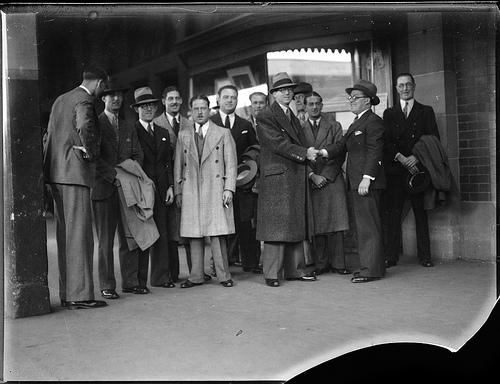What is holding his tie in place?
Write a very short answer. Jacket. How many hats are in the picture?
Answer briefly. 5. Is the pic black and white?
Write a very short answer. Yes. How many men are holding their coats?
Quick response, please. 2. How many people are wearing hats?
Give a very brief answer. 5. 